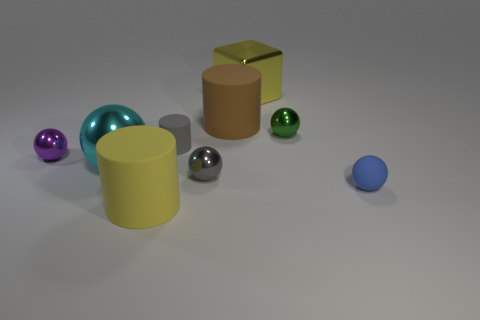Do the small gray thing that is behind the big cyan metallic ball and the blue thing have the same material?
Provide a short and direct response. Yes. Is the number of shiny balls in front of the small green metal thing greater than the number of tiny blue rubber spheres left of the brown thing?
Your answer should be very brief. Yes. How big is the green sphere?
Give a very brief answer. Small. What shape is the tiny gray thing that is made of the same material as the big cyan sphere?
Offer a very short reply. Sphere. Is the shape of the small gray object that is behind the big sphere the same as  the brown matte object?
Offer a terse response. Yes. How many objects are either small gray cylinders or green metallic spheres?
Give a very brief answer. 2. There is a cylinder that is both to the left of the small gray metal sphere and behind the cyan thing; what material is it?
Keep it short and to the point. Rubber. Is the size of the purple shiny sphere the same as the cyan thing?
Your response must be concise. No. How big is the yellow thing that is right of the large yellow object that is in front of the purple shiny object?
Provide a succinct answer. Large. What number of rubber objects are both in front of the large brown rubber object and to the left of the yellow metallic cube?
Provide a short and direct response. 2. 